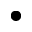Convert formula to latex. <formula><loc_0><loc_0><loc_500><loc_500>\bullet</formula> 